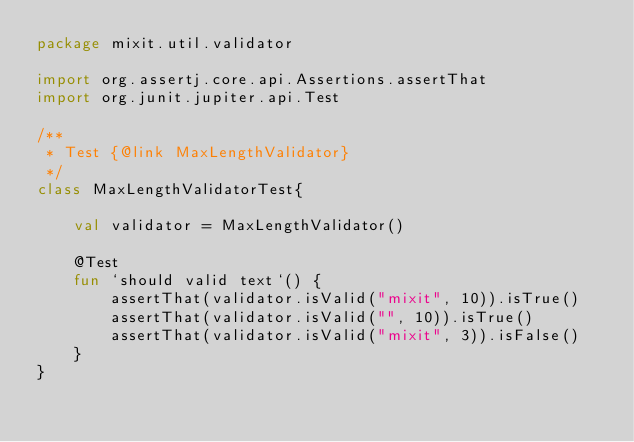Convert code to text. <code><loc_0><loc_0><loc_500><loc_500><_Kotlin_>package mixit.util.validator

import org.assertj.core.api.Assertions.assertThat
import org.junit.jupiter.api.Test

/**
 * Test {@link MaxLengthValidator}
 */
class MaxLengthValidatorTest{

    val validator = MaxLengthValidator()

    @Test
    fun `should valid text`() {
        assertThat(validator.isValid("mixit", 10)).isTrue()
        assertThat(validator.isValid("", 10)).isTrue()
        assertThat(validator.isValid("mixit", 3)).isFalse()
    }
}</code> 